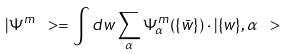<formula> <loc_0><loc_0><loc_500><loc_500>| \Psi ^ { m } \ > = \int d w \sum _ { \alpha } \Psi ^ { m } _ { \alpha } ( \{ \bar { w } \} ) \cdot | \{ w \} , \alpha \ ></formula> 